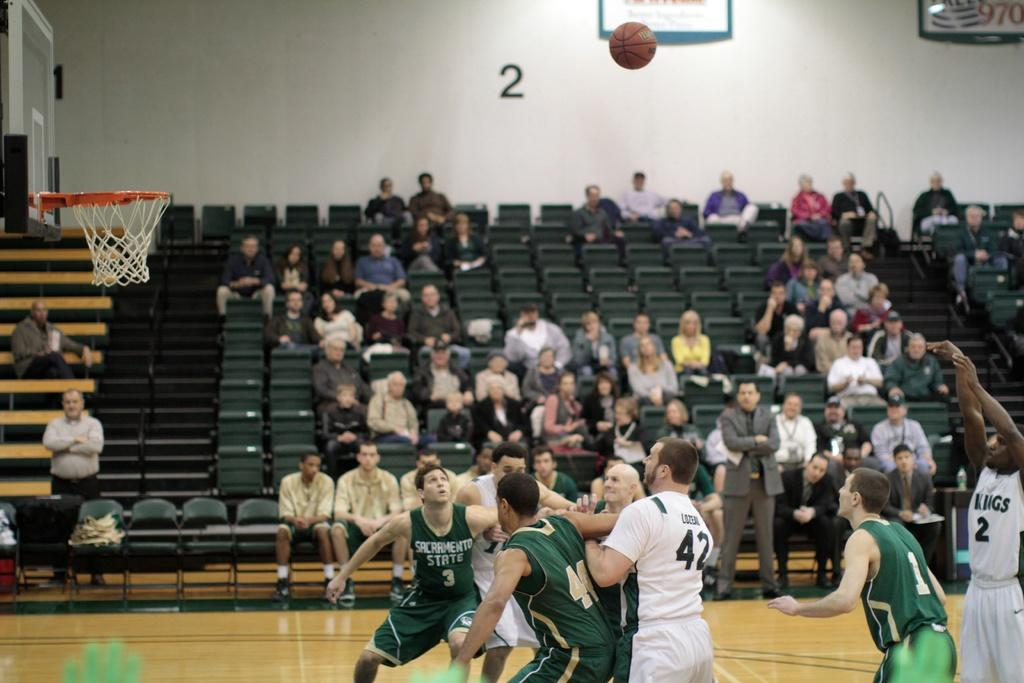<image>
Describe the image concisely. Player number 2 in white shoots the basketball while players in green try to box out to grab a rebound. 